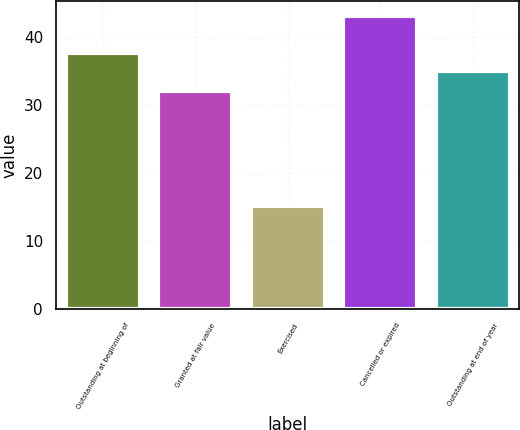Convert chart to OTSL. <chart><loc_0><loc_0><loc_500><loc_500><bar_chart><fcel>Outstanding at beginning of<fcel>Granted at fair value<fcel>Exercised<fcel>Cancelled or expired<fcel>Outstanding at end of year<nl><fcel>37.72<fcel>32.02<fcel>15.16<fcel>43.1<fcel>34.93<nl></chart> 